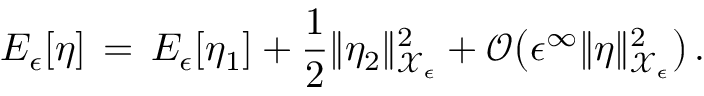Convert formula to latex. <formula><loc_0><loc_0><loc_500><loc_500>E _ { \epsilon } [ \eta ] \, = \, E _ { \epsilon } [ \eta _ { 1 } ] + \frac { 1 } { 2 } \| \eta _ { 2 } \| _ { \mathcal { X } _ { \epsilon } } ^ { 2 } + \mathcal { O } \left ( \epsilon ^ { \infty } \| \eta \| _ { \mathcal { X } _ { \epsilon } } ^ { 2 } \right ) \, .</formula> 